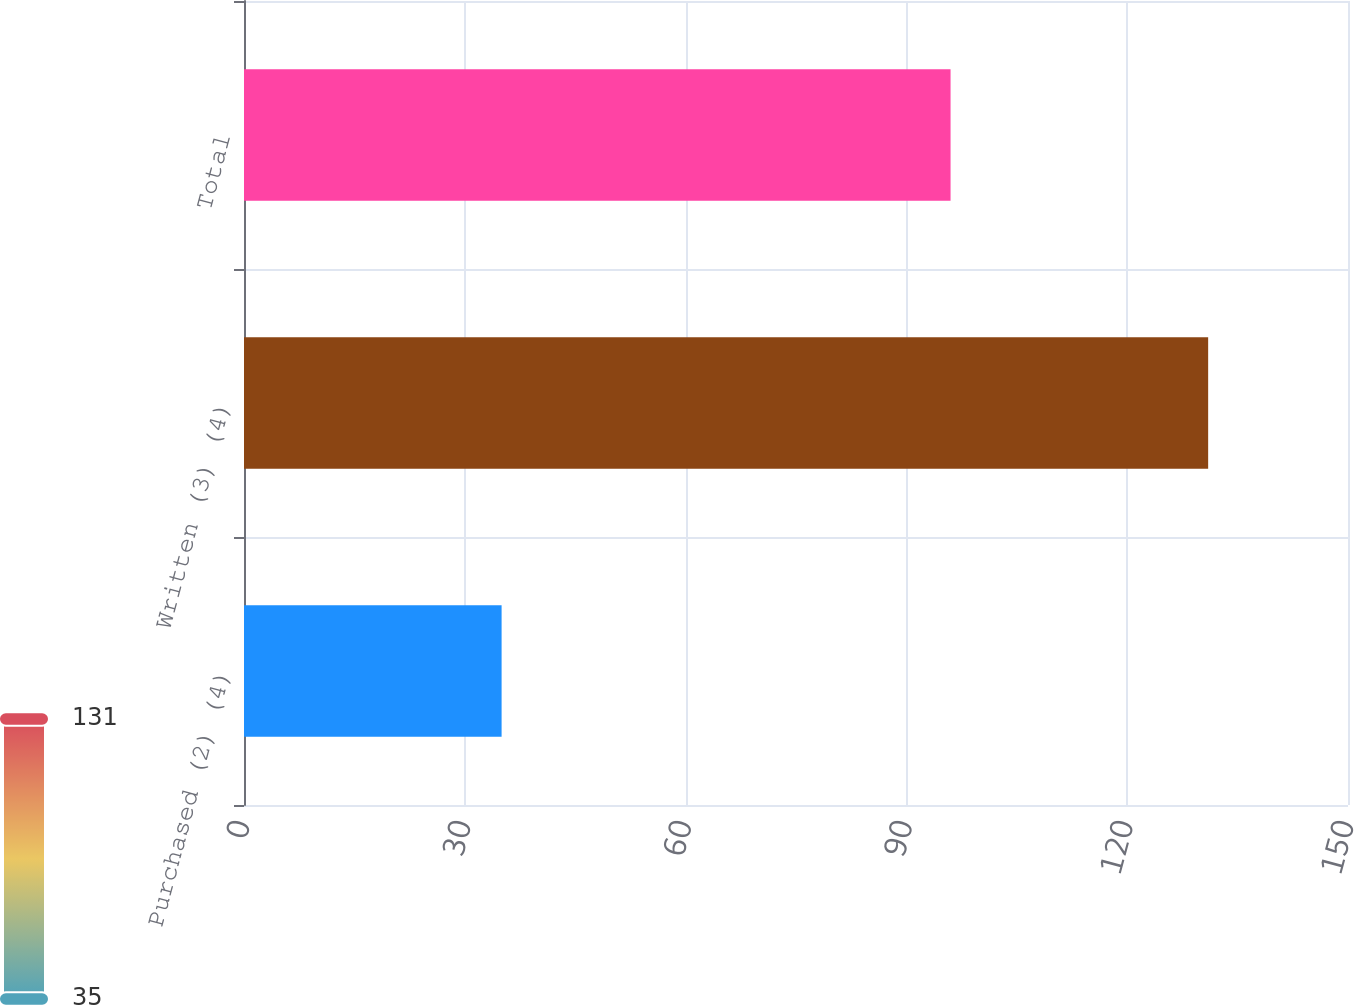<chart> <loc_0><loc_0><loc_500><loc_500><bar_chart><fcel>Purchased (2) (4)<fcel>Written (3) (4)<fcel>Total<nl><fcel>35<fcel>131<fcel>96<nl></chart> 